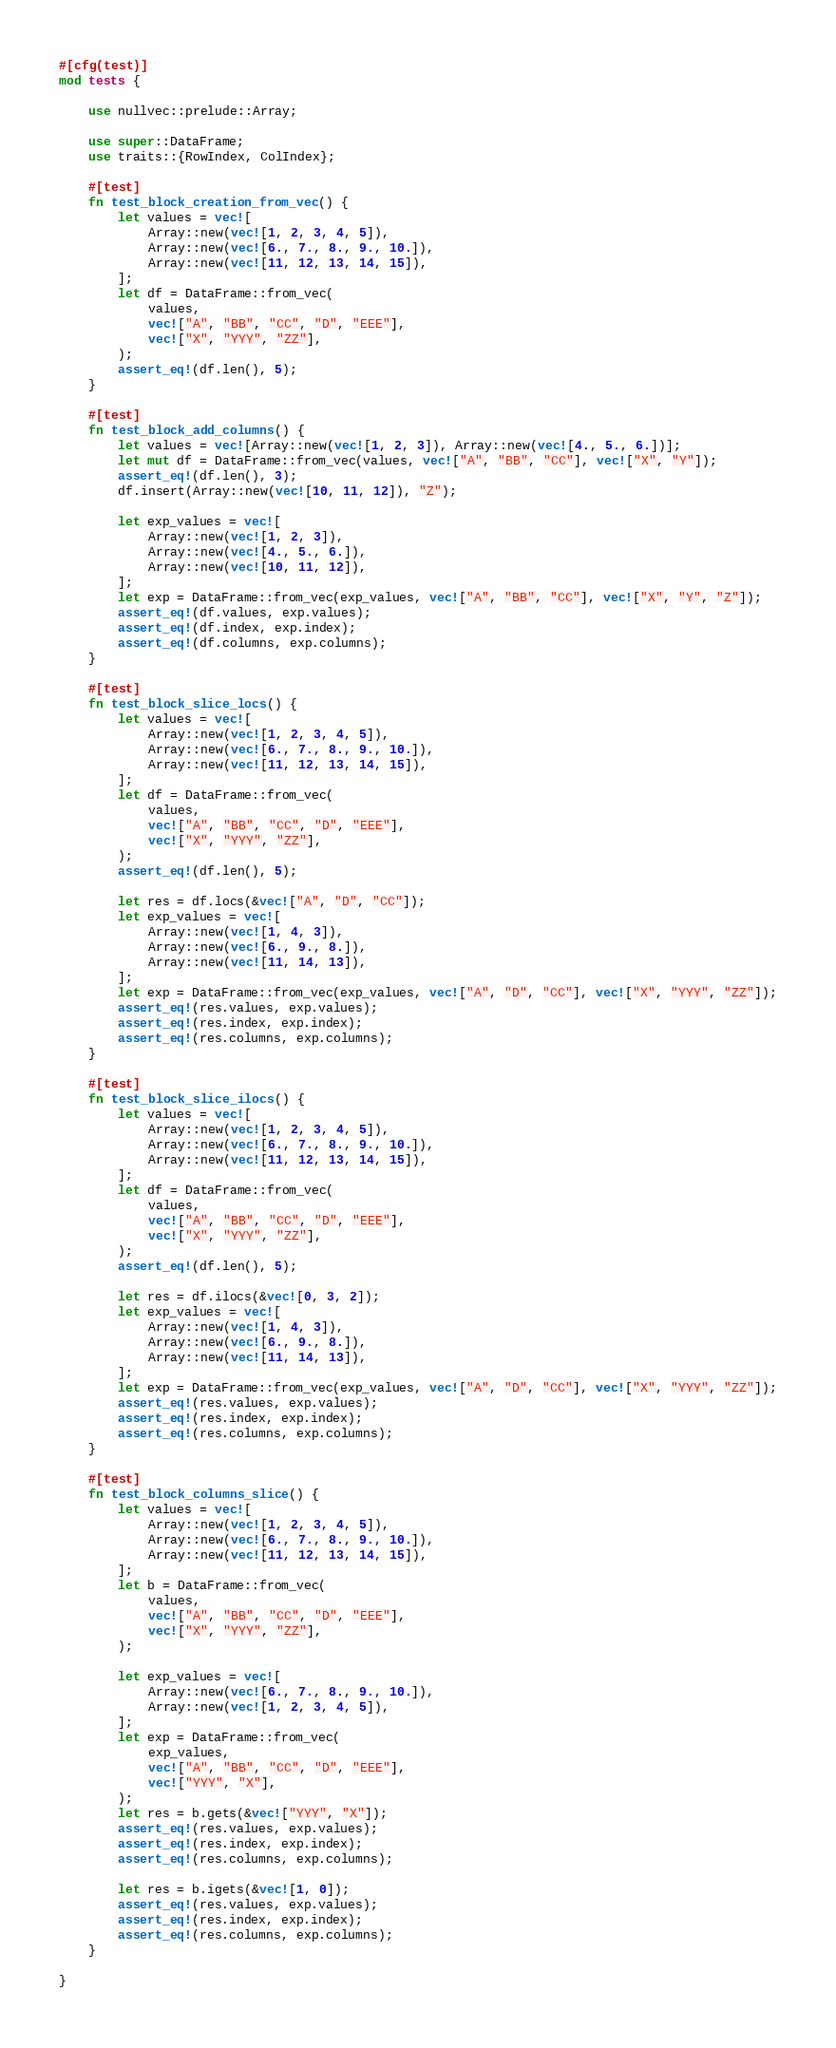Convert code to text. <code><loc_0><loc_0><loc_500><loc_500><_Rust_>
#[cfg(test)]
mod tests {

    use nullvec::prelude::Array;

    use super::DataFrame;
    use traits::{RowIndex, ColIndex};

    #[test]
    fn test_block_creation_from_vec() {
        let values = vec![
            Array::new(vec![1, 2, 3, 4, 5]),
            Array::new(vec![6., 7., 8., 9., 10.]),
            Array::new(vec![11, 12, 13, 14, 15]),
        ];
        let df = DataFrame::from_vec(
            values,
            vec!["A", "BB", "CC", "D", "EEE"],
            vec!["X", "YYY", "ZZ"],
        );
        assert_eq!(df.len(), 5);
    }

    #[test]
    fn test_block_add_columns() {
        let values = vec![Array::new(vec![1, 2, 3]), Array::new(vec![4., 5., 6.])];
        let mut df = DataFrame::from_vec(values, vec!["A", "BB", "CC"], vec!["X", "Y"]);
        assert_eq!(df.len(), 3);
        df.insert(Array::new(vec![10, 11, 12]), "Z");

        let exp_values = vec![
            Array::new(vec![1, 2, 3]),
            Array::new(vec![4., 5., 6.]),
            Array::new(vec![10, 11, 12]),
        ];
        let exp = DataFrame::from_vec(exp_values, vec!["A", "BB", "CC"], vec!["X", "Y", "Z"]);
        assert_eq!(df.values, exp.values);
        assert_eq!(df.index, exp.index);
        assert_eq!(df.columns, exp.columns);
    }

    #[test]
    fn test_block_slice_locs() {
        let values = vec![
            Array::new(vec![1, 2, 3, 4, 5]),
            Array::new(vec![6., 7., 8., 9., 10.]),
            Array::new(vec![11, 12, 13, 14, 15]),
        ];
        let df = DataFrame::from_vec(
            values,
            vec!["A", "BB", "CC", "D", "EEE"],
            vec!["X", "YYY", "ZZ"],
        );
        assert_eq!(df.len(), 5);

        let res = df.locs(&vec!["A", "D", "CC"]);
        let exp_values = vec![
            Array::new(vec![1, 4, 3]),
            Array::new(vec![6., 9., 8.]),
            Array::new(vec![11, 14, 13]),
        ];
        let exp = DataFrame::from_vec(exp_values, vec!["A", "D", "CC"], vec!["X", "YYY", "ZZ"]);
        assert_eq!(res.values, exp.values);
        assert_eq!(res.index, exp.index);
        assert_eq!(res.columns, exp.columns);
    }

    #[test]
    fn test_block_slice_ilocs() {
        let values = vec![
            Array::new(vec![1, 2, 3, 4, 5]),
            Array::new(vec![6., 7., 8., 9., 10.]),
            Array::new(vec![11, 12, 13, 14, 15]),
        ];
        let df = DataFrame::from_vec(
            values,
            vec!["A", "BB", "CC", "D", "EEE"],
            vec!["X", "YYY", "ZZ"],
        );
        assert_eq!(df.len(), 5);

        let res = df.ilocs(&vec![0, 3, 2]);
        let exp_values = vec![
            Array::new(vec![1, 4, 3]),
            Array::new(vec![6., 9., 8.]),
            Array::new(vec![11, 14, 13]),
        ];
        let exp = DataFrame::from_vec(exp_values, vec!["A", "D", "CC"], vec!["X", "YYY", "ZZ"]);
        assert_eq!(res.values, exp.values);
        assert_eq!(res.index, exp.index);
        assert_eq!(res.columns, exp.columns);
    }

    #[test]
    fn test_block_columns_slice() {
        let values = vec![
            Array::new(vec![1, 2, 3, 4, 5]),
            Array::new(vec![6., 7., 8., 9., 10.]),
            Array::new(vec![11, 12, 13, 14, 15]),
        ];
        let b = DataFrame::from_vec(
            values,
            vec!["A", "BB", "CC", "D", "EEE"],
            vec!["X", "YYY", "ZZ"],
        );

        let exp_values = vec![
            Array::new(vec![6., 7., 8., 9., 10.]),
            Array::new(vec![1, 2, 3, 4, 5]),
        ];
        let exp = DataFrame::from_vec(
            exp_values,
            vec!["A", "BB", "CC", "D", "EEE"],
            vec!["YYY", "X"],
        );
        let res = b.gets(&vec!["YYY", "X"]);
        assert_eq!(res.values, exp.values);
        assert_eq!(res.index, exp.index);
        assert_eq!(res.columns, exp.columns);

        let res = b.igets(&vec![1, 0]);
        assert_eq!(res.values, exp.values);
        assert_eq!(res.index, exp.index);
        assert_eq!(res.columns, exp.columns);
    }

}
</code> 